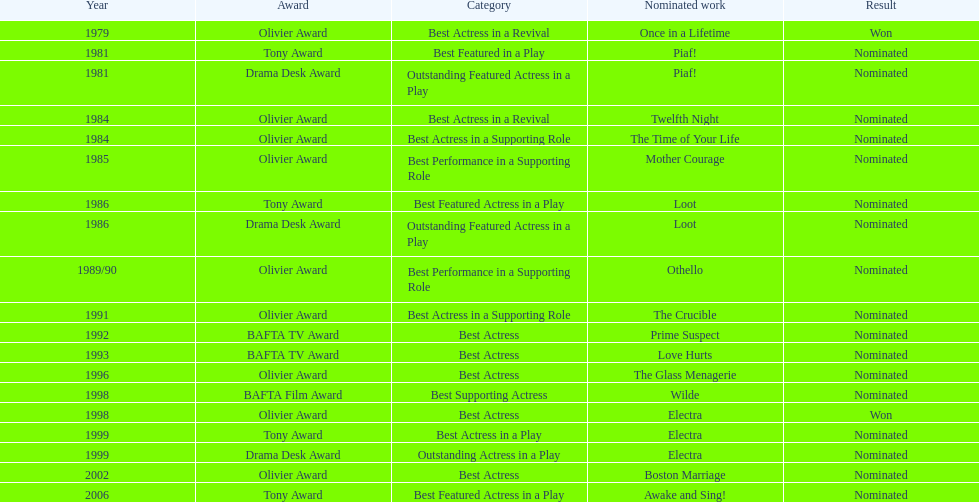In 1981, for which play was wanamaker nominated for best featured actor in a play? Piaf!. 